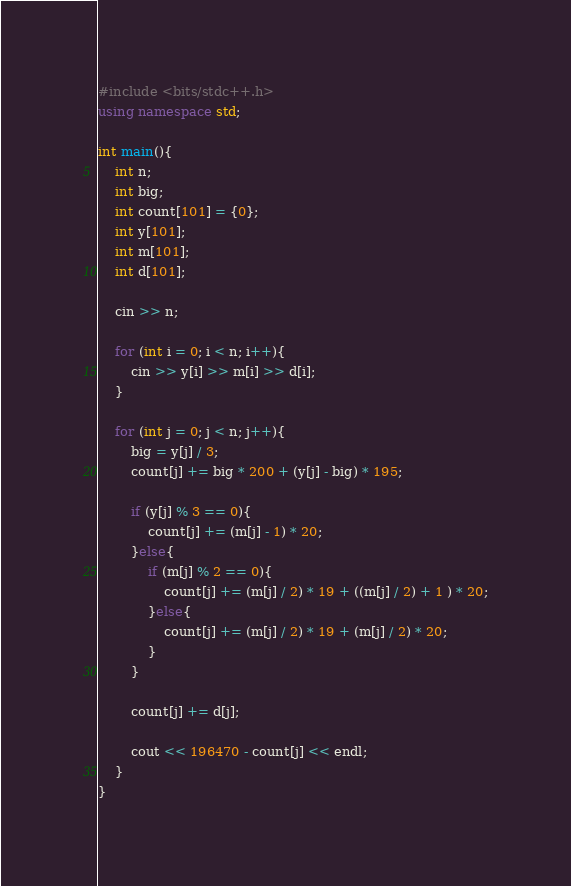<code> <loc_0><loc_0><loc_500><loc_500><_C++_>#include <bits/stdc++.h>
using namespace std;

int main(){
    int n;
    int big;
    int count[101] = {0};
    int y[101];
    int m[101];
    int d[101];
    
    cin >> n;
    
    for (int i = 0; i < n; i++){
        cin >> y[i] >> m[i] >> d[i];
    }
    
    for (int j = 0; j < n; j++){
        big = y[j] / 3;
        count[j] += big * 200 + (y[j] - big) * 195;
        
        if (y[j] % 3 == 0){
            count[j] += (m[j] - 1) * 20;
        }else{
            if (m[j] % 2 == 0){
                count[j] += (m[j] / 2) * 19 + ((m[j] / 2) + 1 ) * 20;
            }else{
                count[j] += (m[j] / 2) * 19 + (m[j] / 2) * 20;
            }
        }
        
        count[j] += d[j];
        
        cout << 196470 - count[j] << endl;
    }
}
</code> 